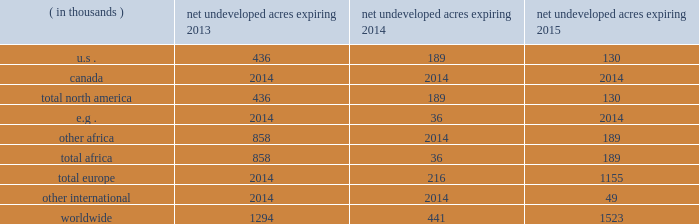In the ordinary course of business , based on our evaluations of certain geologic trends and prospective economics , we have allowed certain lease acreage to expire and may allow additional acreage to expire in the future .
If production is not established or we take no other action to extend the terms of the leases , licenses , or concessions , undeveloped acreage listed in the table below will expire over the next three years .
We plan to continue the terms of many of these licenses and concession areas or retain leases through operational or administrative actions. .
Marketing and midstream our e&p segment includes activities related to the marketing and transportation of substantially all of our liquid hydrocarbon and natural gas production .
These activities include the transportation of production to market centers , the sale of commodities to third parties and storage of production .
We balance our various sales , storage and transportation positions through what we call supply optimization , which can include the purchase of commodities from third parties for resale .
Supply optimization serves to aggregate volumes in order to satisfy transportation commitments and to achieve flexibility within product types and delivery points .
As discussed previously , we currently own and operate gathering systems and other midstream assets in some of our production areas .
We are continually evaluating value-added investments in midstream infrastructure or in capacity in third-party systems .
Delivery commitments we have committed to deliver quantities of crude oil and natural gas to customers under a variety of contracts .
As of december 31 , 2012 , those contracts for fixed and determinable amounts relate primarily to eagle ford liquid hydrocarbon production .
A minimum of 54 mbbld is to be delivered at variable pricing through mid-2017 under two contracts .
Our current production rates and proved reserves related to the eagle ford shale are sufficient to meet these commitments , but the contracts also provide for a monetary shortfall penalty or delivery of third-party volumes .
Oil sands mining segment we hold a 20 percent non-operated interest in the aosp , an oil sands mining and upgrading joint venture located in alberta , canada .
The joint venture produces bitumen from oil sands deposits in the athabasca region utilizing mining techniques and upgrades the bitumen to synthetic crude oils and vacuum gas oil .
The aosp 2019s mining and extraction assets are located near fort mcmurray , alberta and include the muskeg river and the jackpine mines .
Gross design capacity of the combined mines is 255000 ( 51000 net to our interest ) barrels of bitumen per day .
The aosp base and expansion 1 scotford upgrader is at fort saskatchewan , northeast of edmonton , alberta .
As of december 31 , 2012 , we own or have rights to participate in developed and undeveloped leases totaling approximately 216000 gross ( 43000 net ) acres .
The underlying developed leases are held for the duration of the project , with royalties payable to the province of alberta .
The five year aosp expansion 1 was completed in 2011 .
The jackpine mine commenced production under a phased start- up in the third quarter of 2010 and began supplying oil sands ore to the base processing facility in the fourth quarter of 2010 .
The upgrader expansion was completed and commenced operations in the second quarter of 2011 .
Synthetic crude oil sales volumes for 2012 were 47 mbbld and net of royalty production was 41 mbbld .
Phase one of debottlenecking opportunities was approved in 2011 and is expected to be completed in the second quarter of 2013 .
Future expansions and additional debottlenecking opportunities remain under review with no formal approvals expected until 2014 .
Current aosp operations use established processes to mine oil sands deposits from an open-pit mine , extract the bitumen and upgrade it into synthetic crude oils .
Ore is mined using traditional truck and shovel mining techniques .
The mined ore passes through primary crushers to reduce the ore chunks in size and is then sent to rotary breakers where the ore chunks are further reduced to smaller particles .
The particles are combined with hot water to create slurry .
The slurry moves through the extraction .
Based on synthetic crude oil sales volumes for 2012 , what are the deemed mbbld due to royalty production? 
Computations: (47 - 41)
Answer: 6.0. 